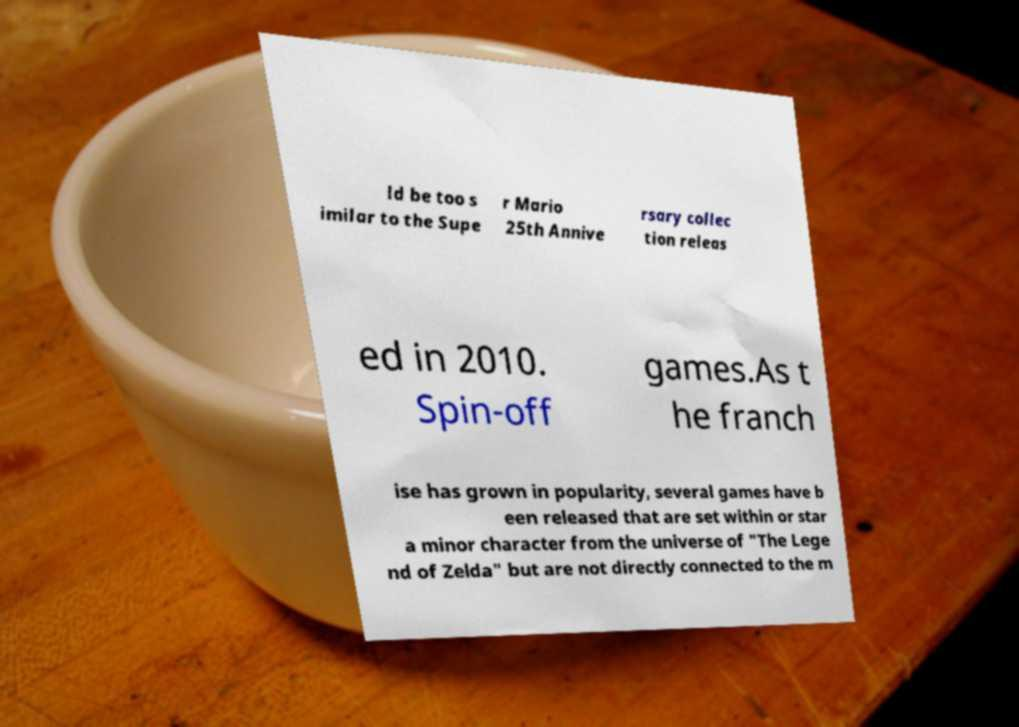Can you accurately transcribe the text from the provided image for me? ld be too s imilar to the Supe r Mario 25th Annive rsary collec tion releas ed in 2010. Spin-off games.As t he franch ise has grown in popularity, several games have b een released that are set within or star a minor character from the universe of "The Lege nd of Zelda" but are not directly connected to the m 